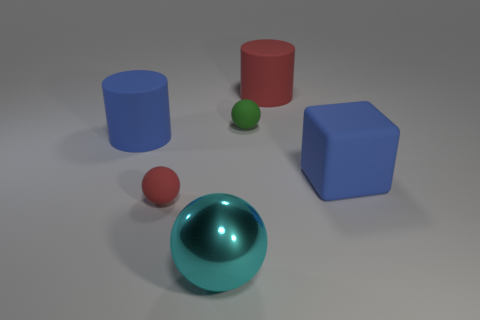How many objects are both behind the cyan thing and to the left of the small green sphere?
Ensure brevity in your answer.  2. Is there any other thing that is the same shape as the small green thing?
Offer a very short reply. Yes. Do the rubber cube and the big thing in front of the large rubber cube have the same color?
Provide a succinct answer. No. What is the shape of the red rubber object that is on the right side of the cyan sphere?
Provide a short and direct response. Cylinder. How many other things are there of the same material as the big sphere?
Provide a succinct answer. 0. What material is the small green ball?
Your answer should be compact. Rubber. What number of big objects are gray objects or blue rubber things?
Offer a terse response. 2. How many red rubber things are in front of the small green rubber sphere?
Your answer should be compact. 1. Is there a small cylinder of the same color as the large ball?
Offer a very short reply. No. What is the shape of the metal thing that is the same size as the cube?
Your answer should be very brief. Sphere. 